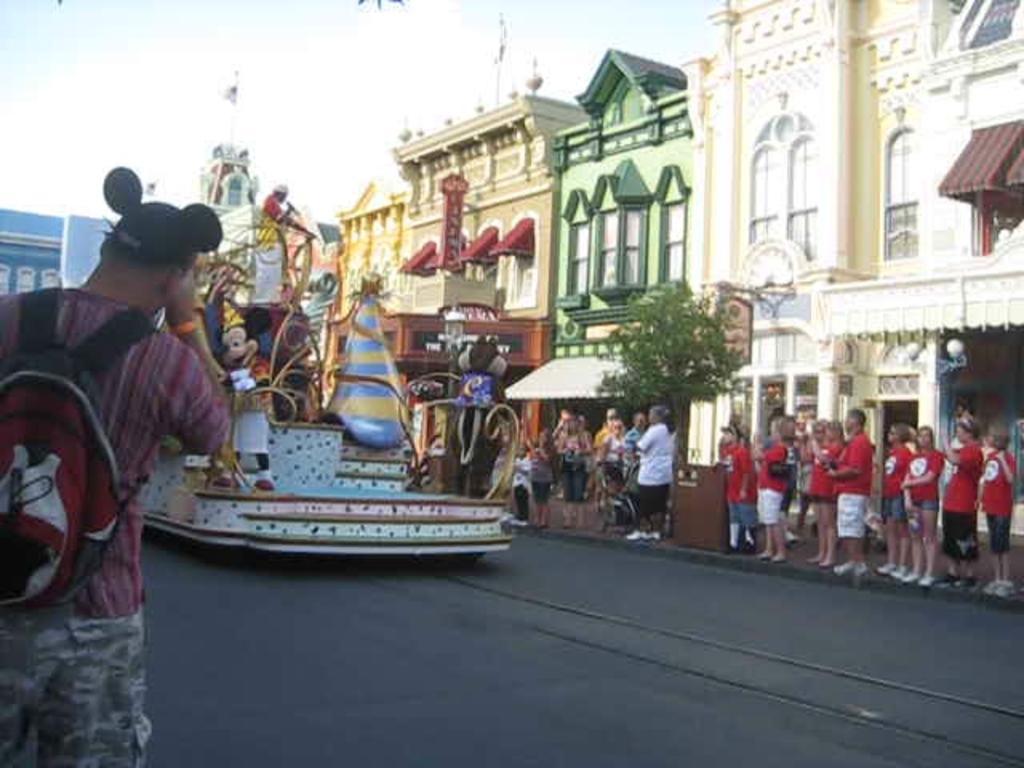How would you summarize this image in a sentence or two? In the center of the image there is a road. There is a vehicle. There are people standing. To the right side of the image there are buildings. At the top of the image there is sky. There is a tree. 